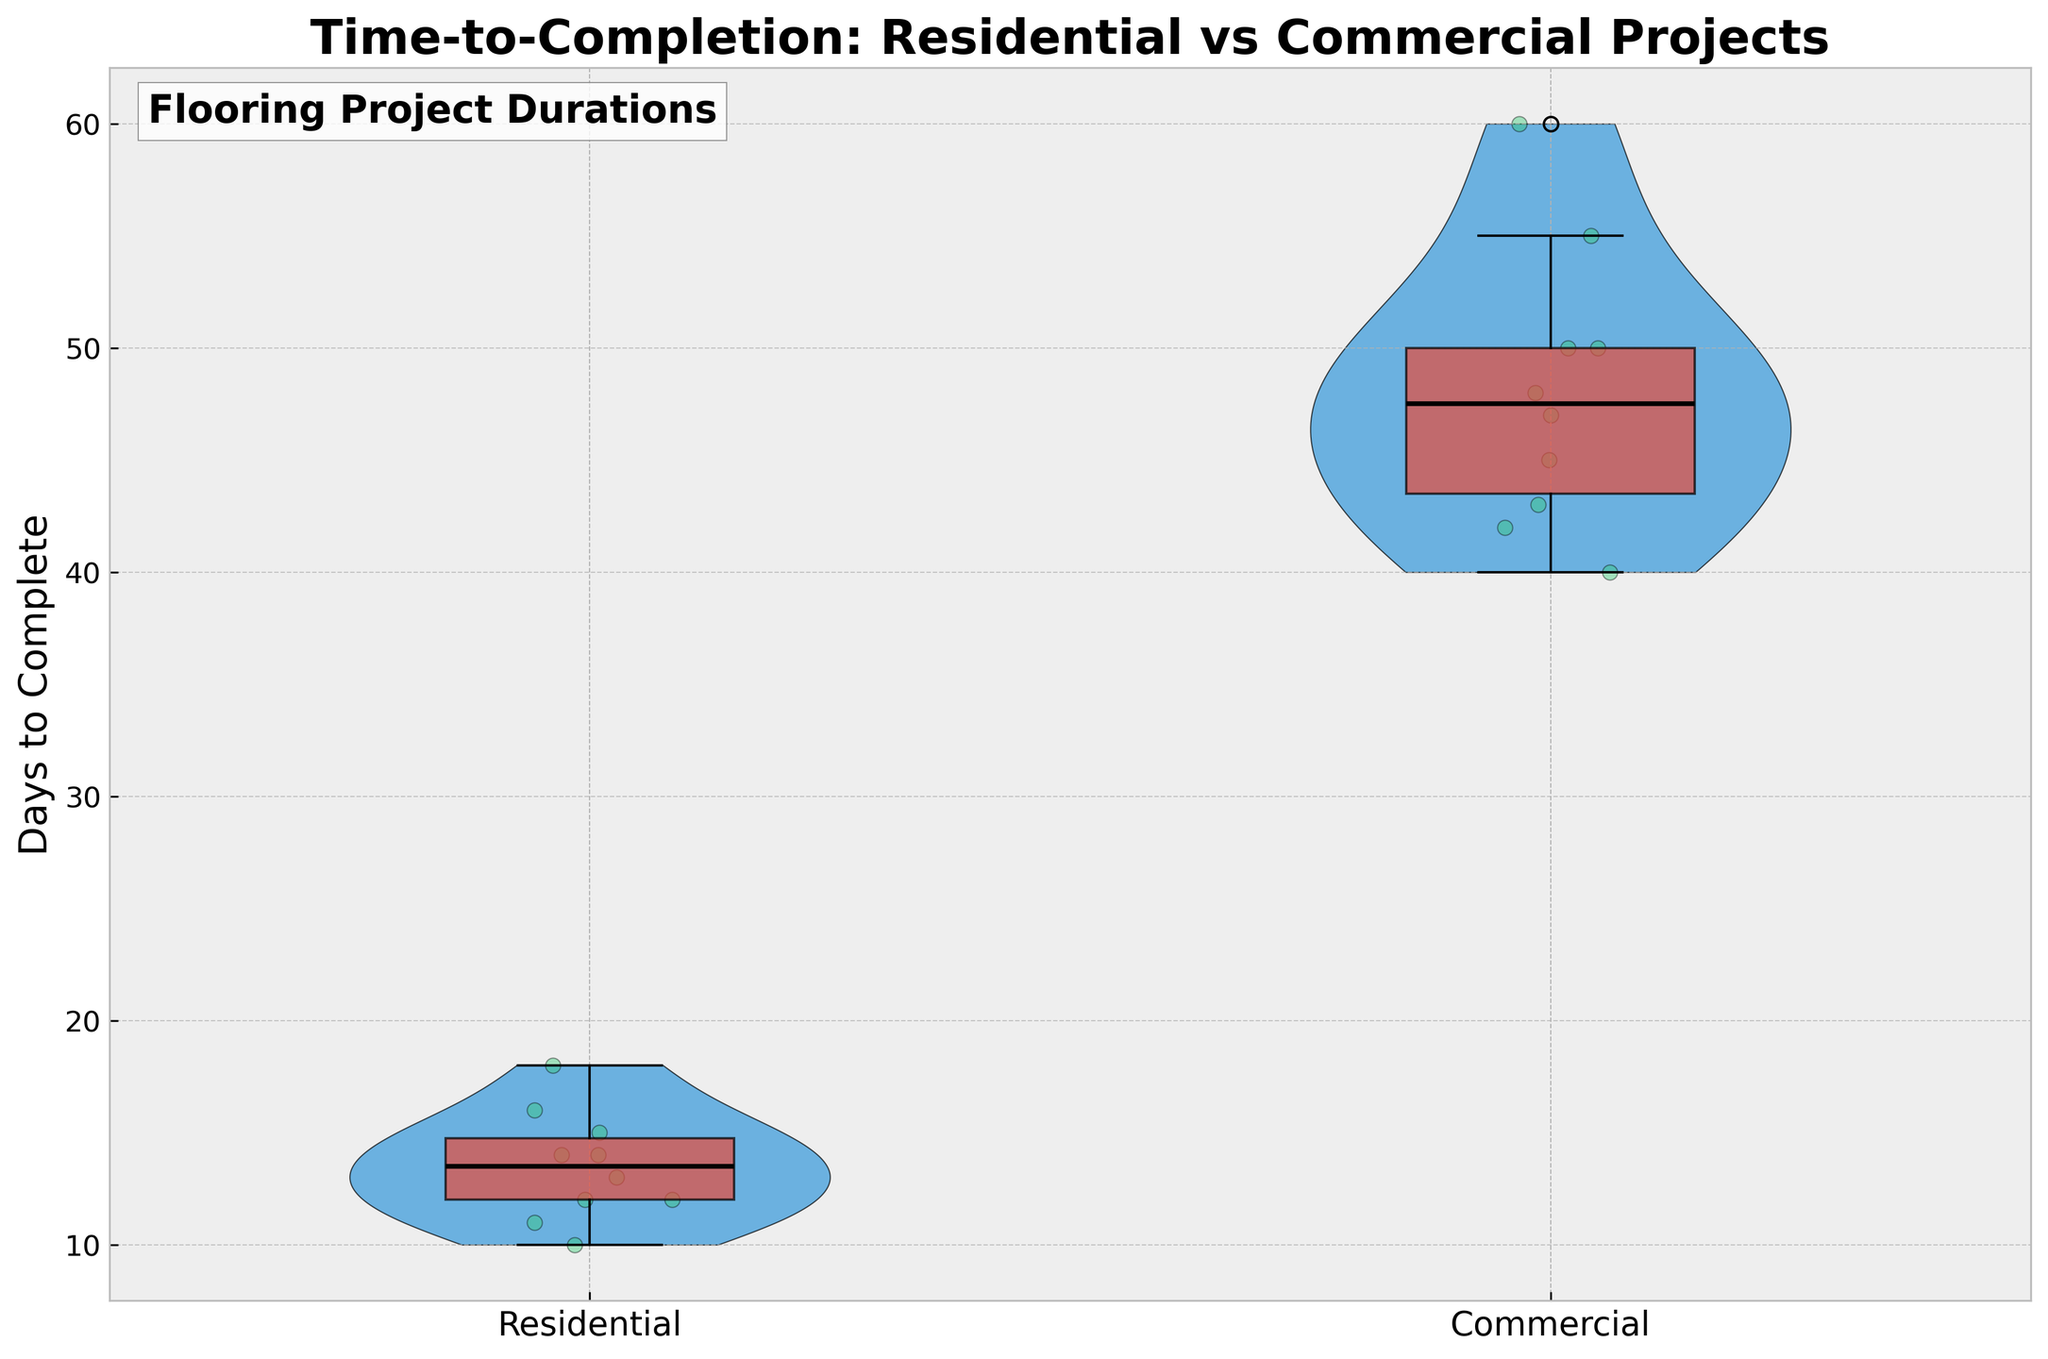What is the title of the plot? The title is located at the top of the plot and is written in a large, bold font.
Answer: Time-to-Completion: Residential vs Commercial Projects What are the labels on the x-axis? The x-axis labels are located at the bottom of the plot and identify the two groups being compared.
Answer: Residential, Commercial How many residential projects are represented in the plot? Count the individual data points represented by jittered green dots on the residential side of the plot.
Answer: 10 Which project type generally takes longer to complete? Compare the spread of the data on the y-axis for both residential and commercial sections. The side with higher values generally takes longer.
Answer: Commercial What is the average time-to-completion for residential projects? Calculate the mean of the time-to-completion values for residential projects: (15 + 12 + 18 + 10 + 14 + 12 + 16 + 13 + 11 + 14) / 10 = 13.5 days.
Answer: 13.5 days What does the box inside the violin plot represent? The box inside the violin plot represents the interquartile range (IQR), with the line inside the box indicating the median value, indicated by the plot's visual cues.
Answer: Interquartile range and median Which group has more variability in time-to-completion? Compare the spread and shape of the violin plots; the group with a wider or taller violin plot has more variability.
Answer: Commercial What is the median time-to-completion for commercial projects? Locate the line inside the box on the commercial side of the plot and read its approximate value from the y-axis.
Answer: Approx. 48 days How does the shape of the violin plots assist in understanding the data distribution? The violin plot shows the probability density of the data at different values, highlighting where the data is most concentrated.
Answer: Shows data concentration and distribution What is the range of days to complete residential projects? Identify the lowest and highest points of the residential violin plot on the y-axis.
Answer: 10 to 18 days 